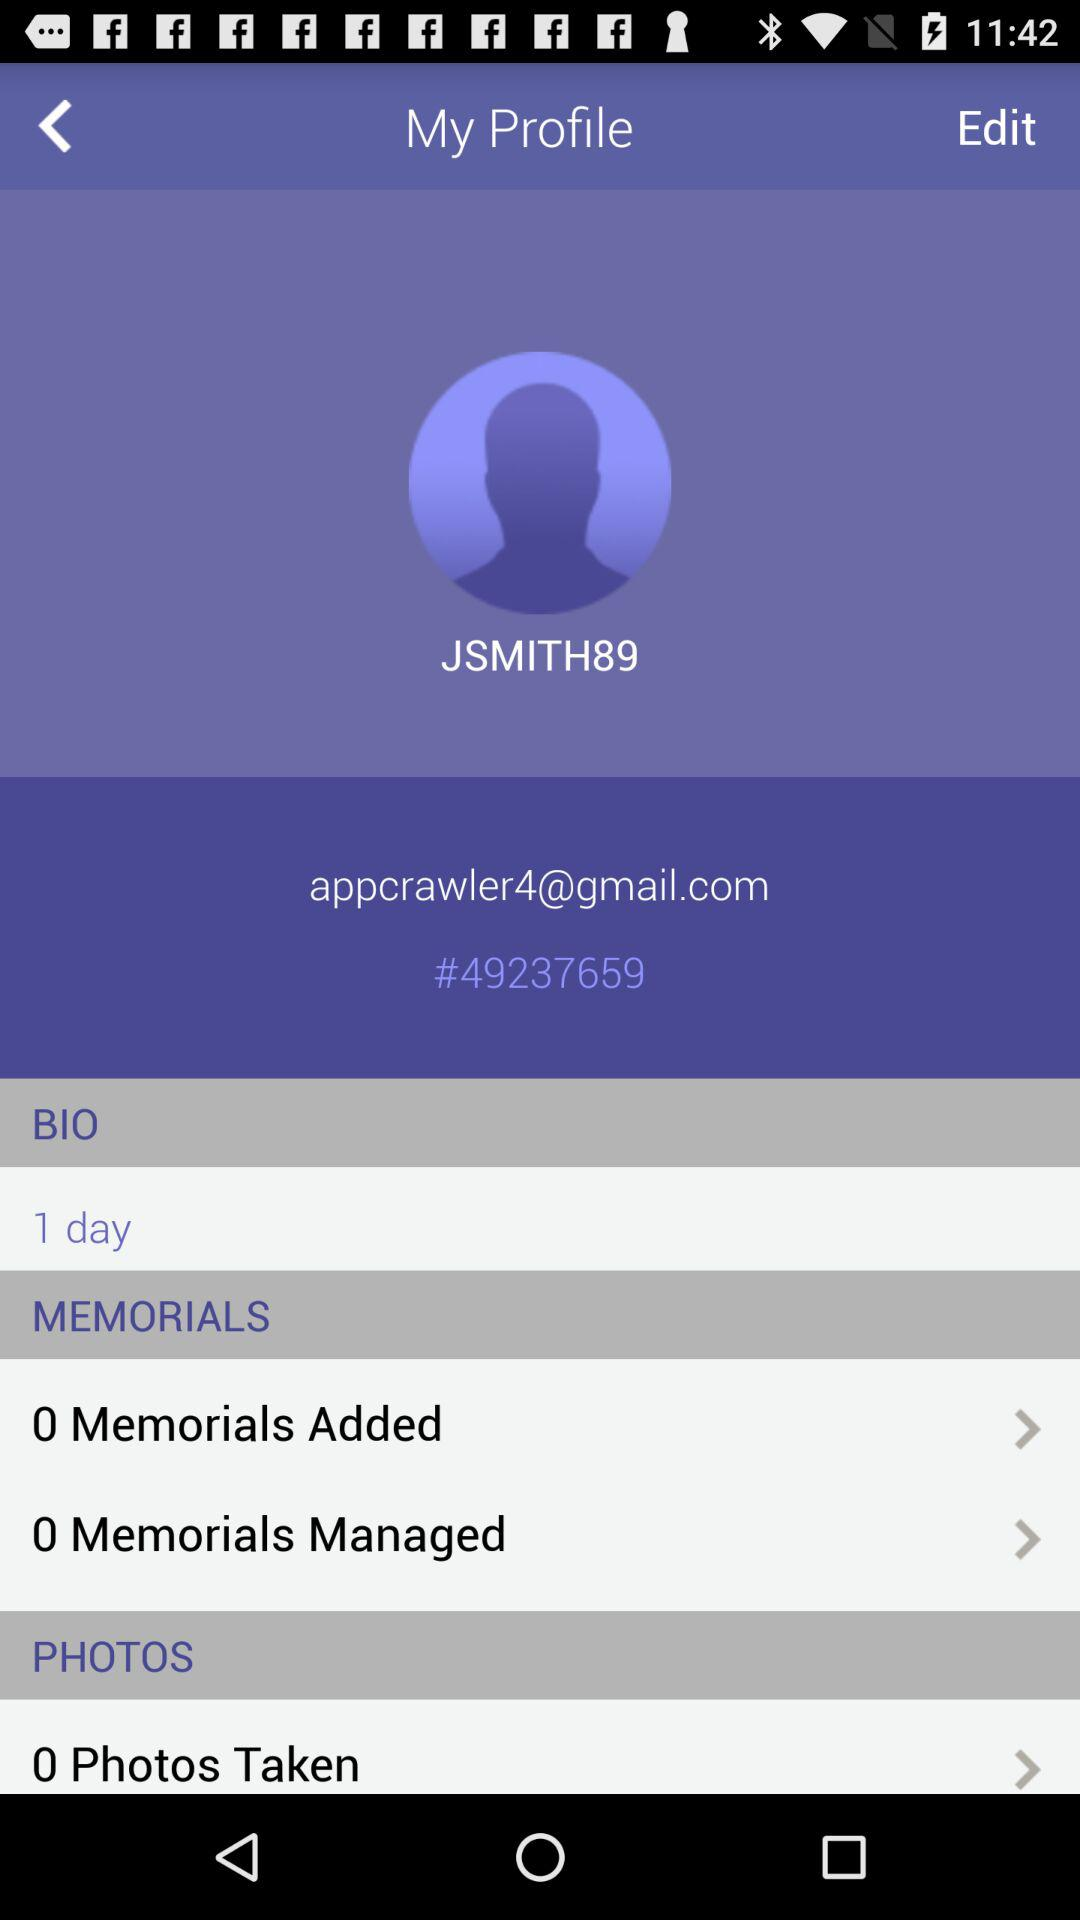What is the email address? The email address is appcrawler4@gmail.com. 